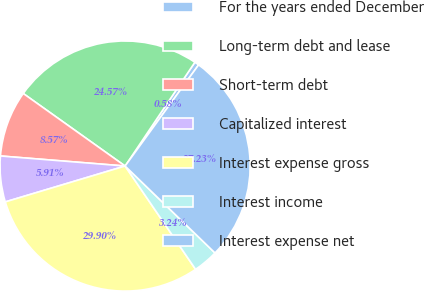<chart> <loc_0><loc_0><loc_500><loc_500><pie_chart><fcel>For the years ended December<fcel>Long-term debt and lease<fcel>Short-term debt<fcel>Capitalized interest<fcel>Interest expense gross<fcel>Interest income<fcel>Interest expense net<nl><fcel>0.58%<fcel>24.57%<fcel>8.57%<fcel>5.91%<fcel>29.9%<fcel>3.24%<fcel>27.23%<nl></chart> 